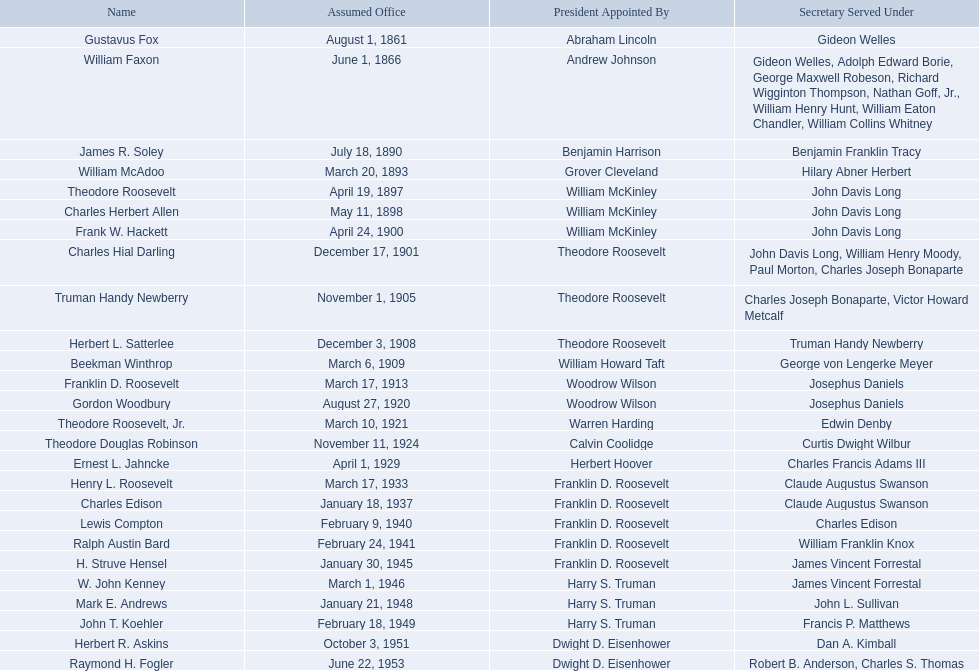What are all the names? Gustavus Fox, William Faxon, James R. Soley, William McAdoo, Theodore Roosevelt, Charles Herbert Allen, Frank W. Hackett, Charles Hial Darling, Truman Handy Newberry, Herbert L. Satterlee, Beekman Winthrop, Franklin D. Roosevelt, Gordon Woodbury, Theodore Roosevelt, Jr., Theodore Douglas Robinson, Ernest L. Jahncke, Henry L. Roosevelt, Charles Edison, Lewis Compton, Ralph Austin Bard, H. Struve Hensel, W. John Kenney, Mark E. Andrews, John T. Koehler, Herbert R. Askins, Raymond H. Fogler. When did they leave office? November 26, 1866, March 3, 1889, March 19, 1893, April 18, 1897, May 10, 1898, April 21, 1900, December 16, 1901, October 30, 1905, November 30, 1908, March 5, 1909, March 16, 1913, August 26, 1920, March 9, 1921, September 30, 1924, March 4, 1929, March 17, 1933, February 22, 1936, January 1, 1940, January 10, 1941, June 24, 1944, February 28, 1946, September 19, 1947, February 15, 1949, October 3, 1951, January 20, 1953, October 4, 1954. And when did raymond h. fogler leave? October 4, 1954. 